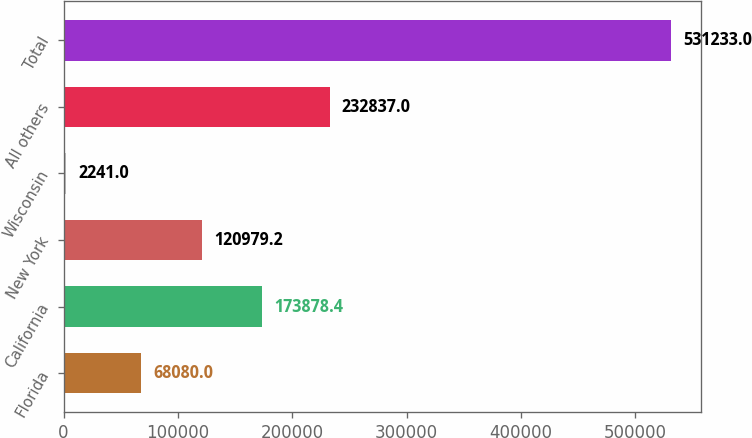Convert chart to OTSL. <chart><loc_0><loc_0><loc_500><loc_500><bar_chart><fcel>Florida<fcel>California<fcel>New York<fcel>Wisconsin<fcel>All others<fcel>Total<nl><fcel>68080<fcel>173878<fcel>120979<fcel>2241<fcel>232837<fcel>531233<nl></chart> 